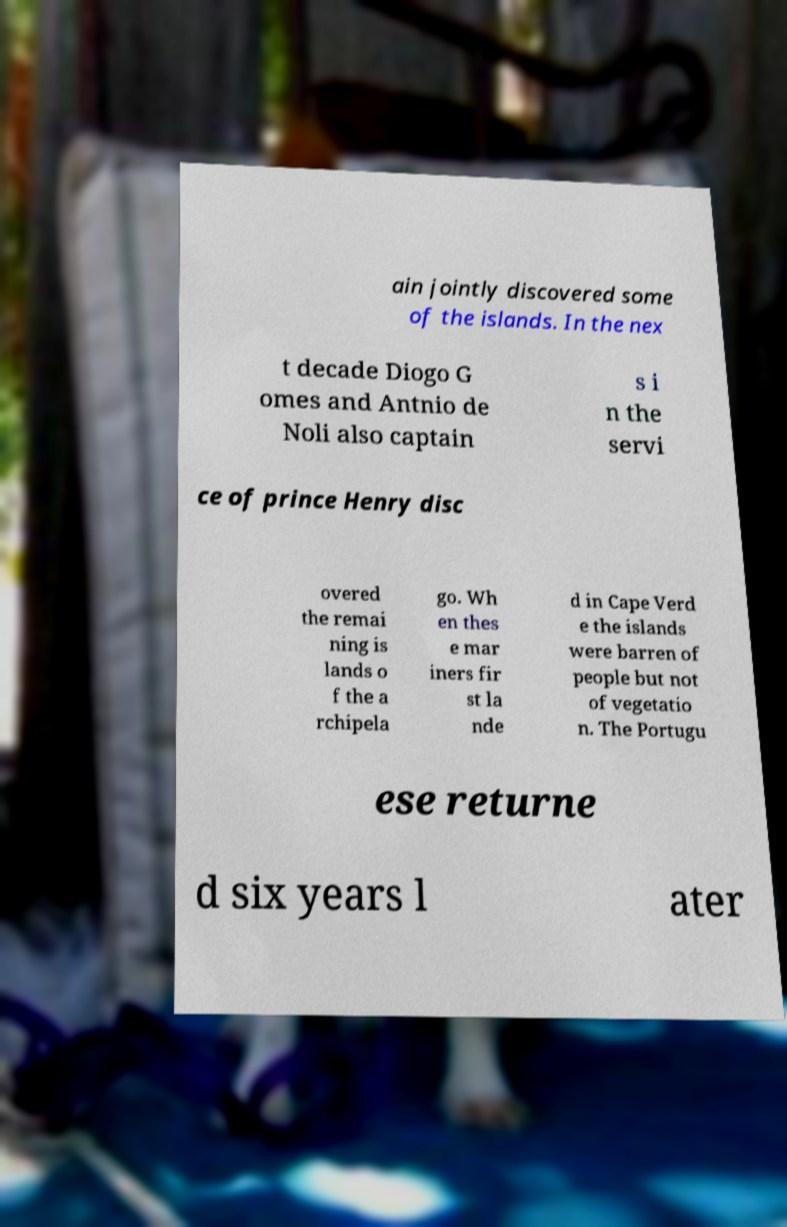Can you accurately transcribe the text from the provided image for me? ain jointly discovered some of the islands. In the nex t decade Diogo G omes and Antnio de Noli also captain s i n the servi ce of prince Henry disc overed the remai ning is lands o f the a rchipela go. Wh en thes e mar iners fir st la nde d in Cape Verd e the islands were barren of people but not of vegetatio n. The Portugu ese returne d six years l ater 